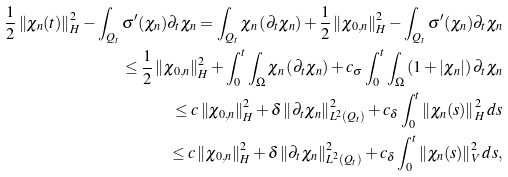Convert formula to latex. <formula><loc_0><loc_0><loc_500><loc_500>\frac { 1 } { 2 } \left \| \chi _ { n } ( t ) \right \| ^ { 2 } _ { H } - \int _ { Q _ { t } } { \sigma ^ { \prime } ( \chi _ { n } ) \partial _ { t } \chi _ { n } } = \int _ { Q _ { t } } { \chi _ { n } \left ( \partial _ { t } \chi _ { n } \right ) } + \frac { 1 } { 2 } \left \| \chi _ { 0 , n } \right \| ^ { 2 } _ { H } - \int _ { Q _ { t } } { \sigma ^ { \prime } ( \chi _ { n } ) \partial _ { t } \chi _ { n } } \\ \leq \frac { 1 } { 2 } \left \| \chi _ { 0 , n } \right \| ^ { 2 } _ { H } + \int _ { 0 } ^ { t } { \int _ { \Omega } { \chi _ { n } \left ( \partial _ { t } \chi _ { n } \right ) } } + c _ { \sigma } \int _ { 0 } ^ { t } { \int _ { \Omega } { \left ( 1 + \left | \chi _ { n } \right | \right ) \partial _ { t } \chi _ { n } } } \\ \leq c \left \| \chi _ { 0 , n } \right \| ^ { 2 } _ { H } + \delta \left \| \partial _ { t } \chi _ { n } \right \| ^ { 2 } _ { L ^ { 2 } ( Q _ { t } ) } + c _ { \delta } \int _ { 0 } ^ { t } { \left \| \chi _ { n } ( s ) \right \| ^ { 2 } _ { H } d s } \\ \leq c \left \| \chi _ { 0 , n } \right \| ^ { 2 } _ { H } + \delta \left \| \partial _ { t } \chi _ { n } \right \| ^ { 2 } _ { L ^ { 2 } ( Q _ { t } ) } + c _ { \delta } \int _ { 0 } ^ { t } { \left \| \chi _ { n } ( s ) \right \| ^ { 2 } _ { V } d s } ,</formula> 